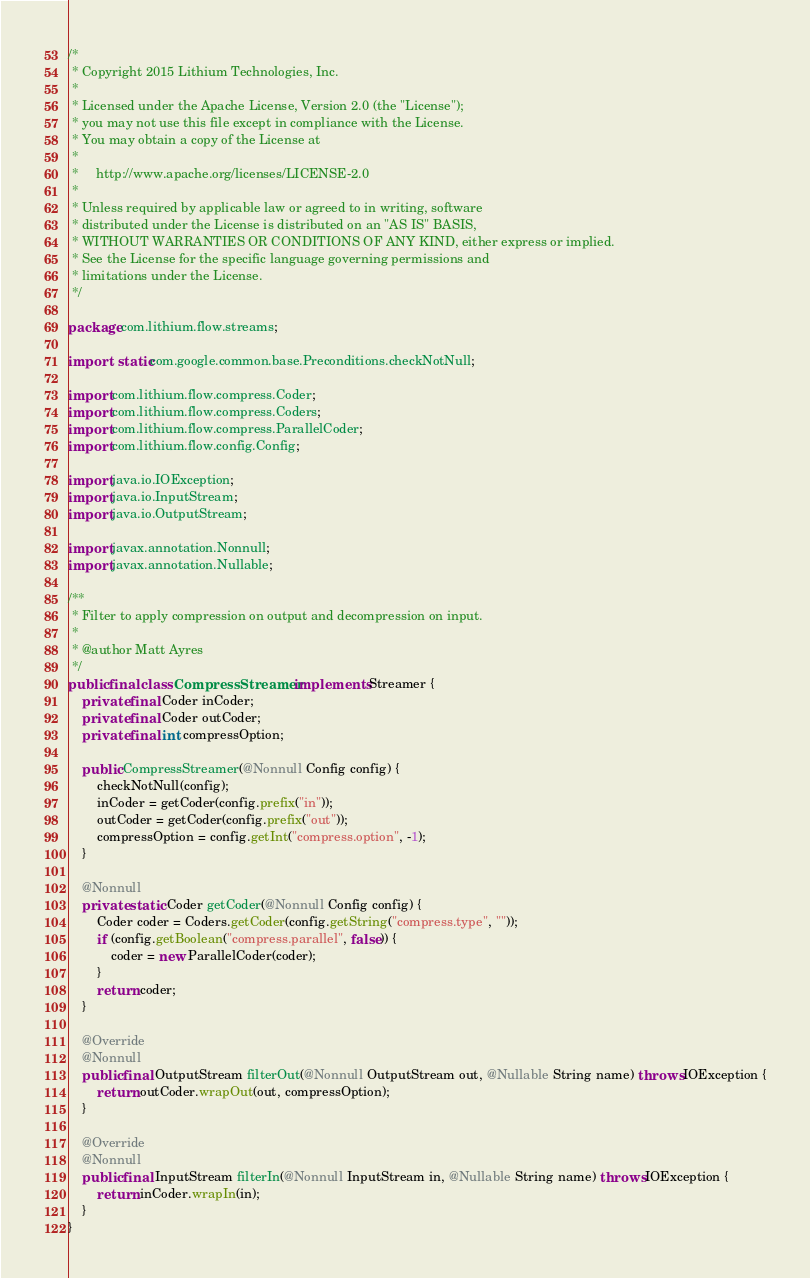<code> <loc_0><loc_0><loc_500><loc_500><_Java_>/*
 * Copyright 2015 Lithium Technologies, Inc.
 *
 * Licensed under the Apache License, Version 2.0 (the "License");
 * you may not use this file except in compliance with the License.
 * You may obtain a copy of the License at
 *
 *     http://www.apache.org/licenses/LICENSE-2.0
 *
 * Unless required by applicable law or agreed to in writing, software
 * distributed under the License is distributed on an "AS IS" BASIS,
 * WITHOUT WARRANTIES OR CONDITIONS OF ANY KIND, either express or implied.
 * See the License for the specific language governing permissions and
 * limitations under the License.
 */

package com.lithium.flow.streams;

import static com.google.common.base.Preconditions.checkNotNull;

import com.lithium.flow.compress.Coder;
import com.lithium.flow.compress.Coders;
import com.lithium.flow.compress.ParallelCoder;
import com.lithium.flow.config.Config;

import java.io.IOException;
import java.io.InputStream;
import java.io.OutputStream;

import javax.annotation.Nonnull;
import javax.annotation.Nullable;

/**
 * Filter to apply compression on output and decompression on input.
 *
 * @author Matt Ayres
 */
public final class CompressStreamer implements Streamer {
	private final Coder inCoder;
	private final Coder outCoder;
	private final int compressOption;

	public CompressStreamer(@Nonnull Config config) {
		checkNotNull(config);
		inCoder = getCoder(config.prefix("in"));
		outCoder = getCoder(config.prefix("out"));
		compressOption = config.getInt("compress.option", -1);
	}

	@Nonnull
	private static Coder getCoder(@Nonnull Config config) {
		Coder coder = Coders.getCoder(config.getString("compress.type", ""));
		if (config.getBoolean("compress.parallel", false)) {
			coder = new ParallelCoder(coder);
		}
		return coder;
	}

	@Override
	@Nonnull
	public final OutputStream filterOut(@Nonnull OutputStream out, @Nullable String name) throws IOException {
		return outCoder.wrapOut(out, compressOption);
	}

	@Override
	@Nonnull
	public final InputStream filterIn(@Nonnull InputStream in, @Nullable String name) throws IOException {
		return inCoder.wrapIn(in);
	}
}
</code> 